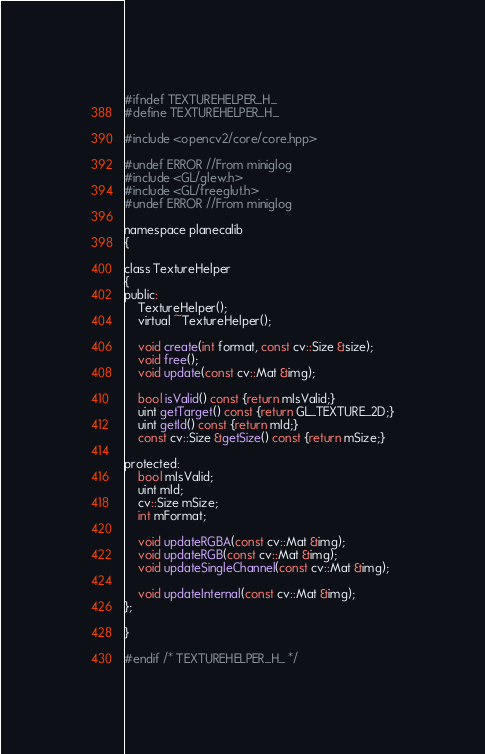Convert code to text. <code><loc_0><loc_0><loc_500><loc_500><_C_>#ifndef TEXTUREHELPER_H_
#define TEXTUREHELPER_H_

#include <opencv2/core/core.hpp>

#undef ERROR //From miniglog
#include <GL/glew.h>
#include <GL/freeglut.h>
#undef ERROR //From miniglog

namespace planecalib
{

class TextureHelper
{
public:
    TextureHelper();
    virtual ~TextureHelper();

    void create(int format, const cv::Size &size);
    void free();
    void update(const cv::Mat &img);

    bool isValid() const {return mIsValid;}
    uint getTarget() const {return GL_TEXTURE_2D;}
    uint getId() const {return mId;}
    const cv::Size &getSize() const {return mSize;}

protected:
    bool mIsValid;
    uint mId;
    cv::Size mSize;
    int mFormat;

    void updateRGBA(const cv::Mat &img);
    void updateRGB(const cv::Mat &img);
    void updateSingleChannel(const cv::Mat &img);

    void updateInternal(const cv::Mat &img);
};

}

#endif /* TEXTUREHELPER_H_ */
</code> 